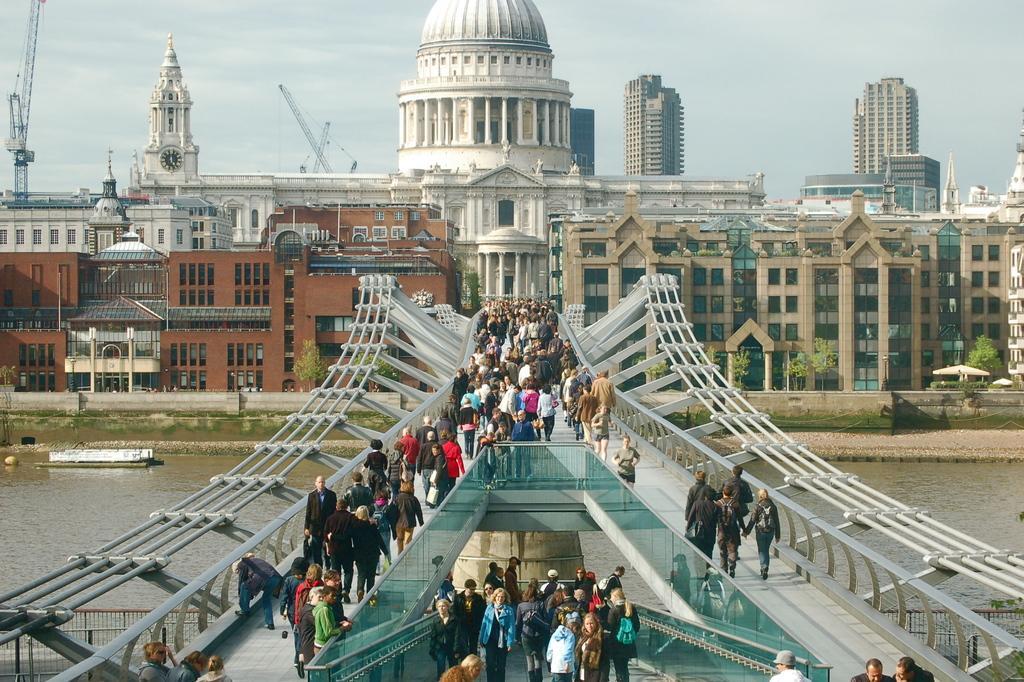How would you summarize this image in a sentence or two? In this image we can see a few people walking on the bridge, there are buildings, windows, there is a wall clock, there are cranes, plants, railings, trees, also we can see the river, and the sky. 